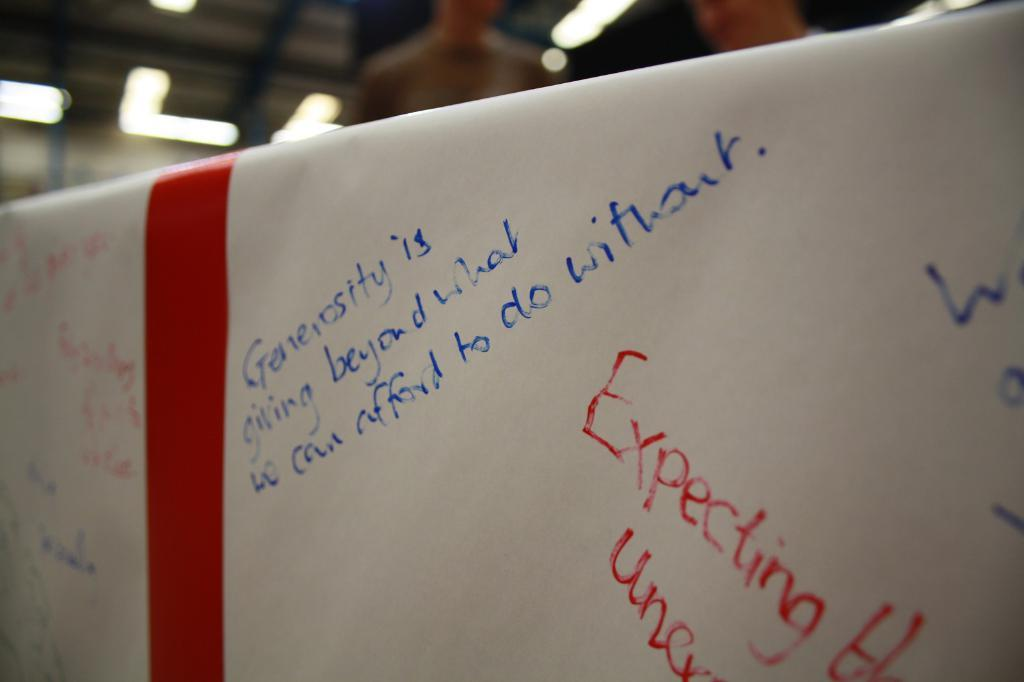<image>
Present a compact description of the photo's key features. "Expecting" is written in red along with some other words in both red and blue. 